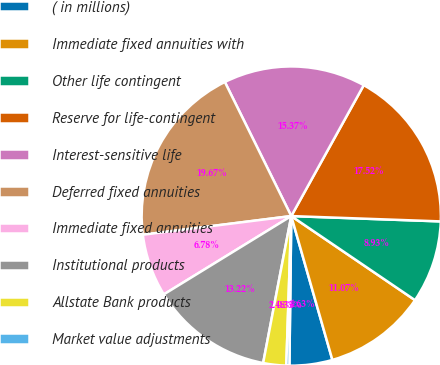Convert chart to OTSL. <chart><loc_0><loc_0><loc_500><loc_500><pie_chart><fcel>( in millions)<fcel>Immediate fixed annuities with<fcel>Other life contingent<fcel>Reserve for life-contingent<fcel>Interest-sensitive life<fcel>Deferred fixed annuities<fcel>Immediate fixed annuities<fcel>Institutional products<fcel>Allstate Bank products<fcel>Market value adjustments<nl><fcel>4.63%<fcel>11.07%<fcel>8.93%<fcel>17.52%<fcel>15.37%<fcel>19.67%<fcel>6.78%<fcel>13.22%<fcel>2.48%<fcel>0.33%<nl></chart> 